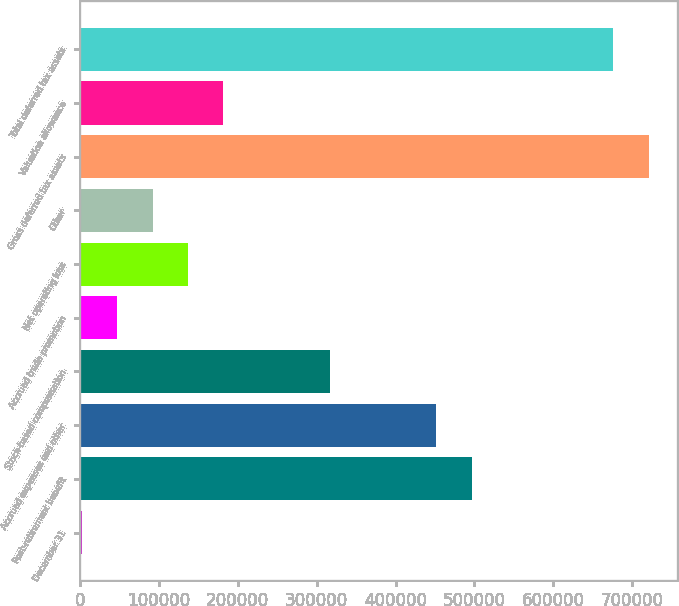<chart> <loc_0><loc_0><loc_500><loc_500><bar_chart><fcel>December 31<fcel>Post-retirement benefit<fcel>Accrued expenses and other<fcel>Stock-based compensation<fcel>Accrued trade promotion<fcel>Net operating loss<fcel>Other<fcel>Gross deferred tax assets<fcel>Valuation allowance<fcel>Total deferred tax assets<nl><fcel>2007<fcel>496283<fcel>451349<fcel>316546<fcel>46941.2<fcel>136810<fcel>91875.4<fcel>720954<fcel>181744<fcel>676020<nl></chart> 